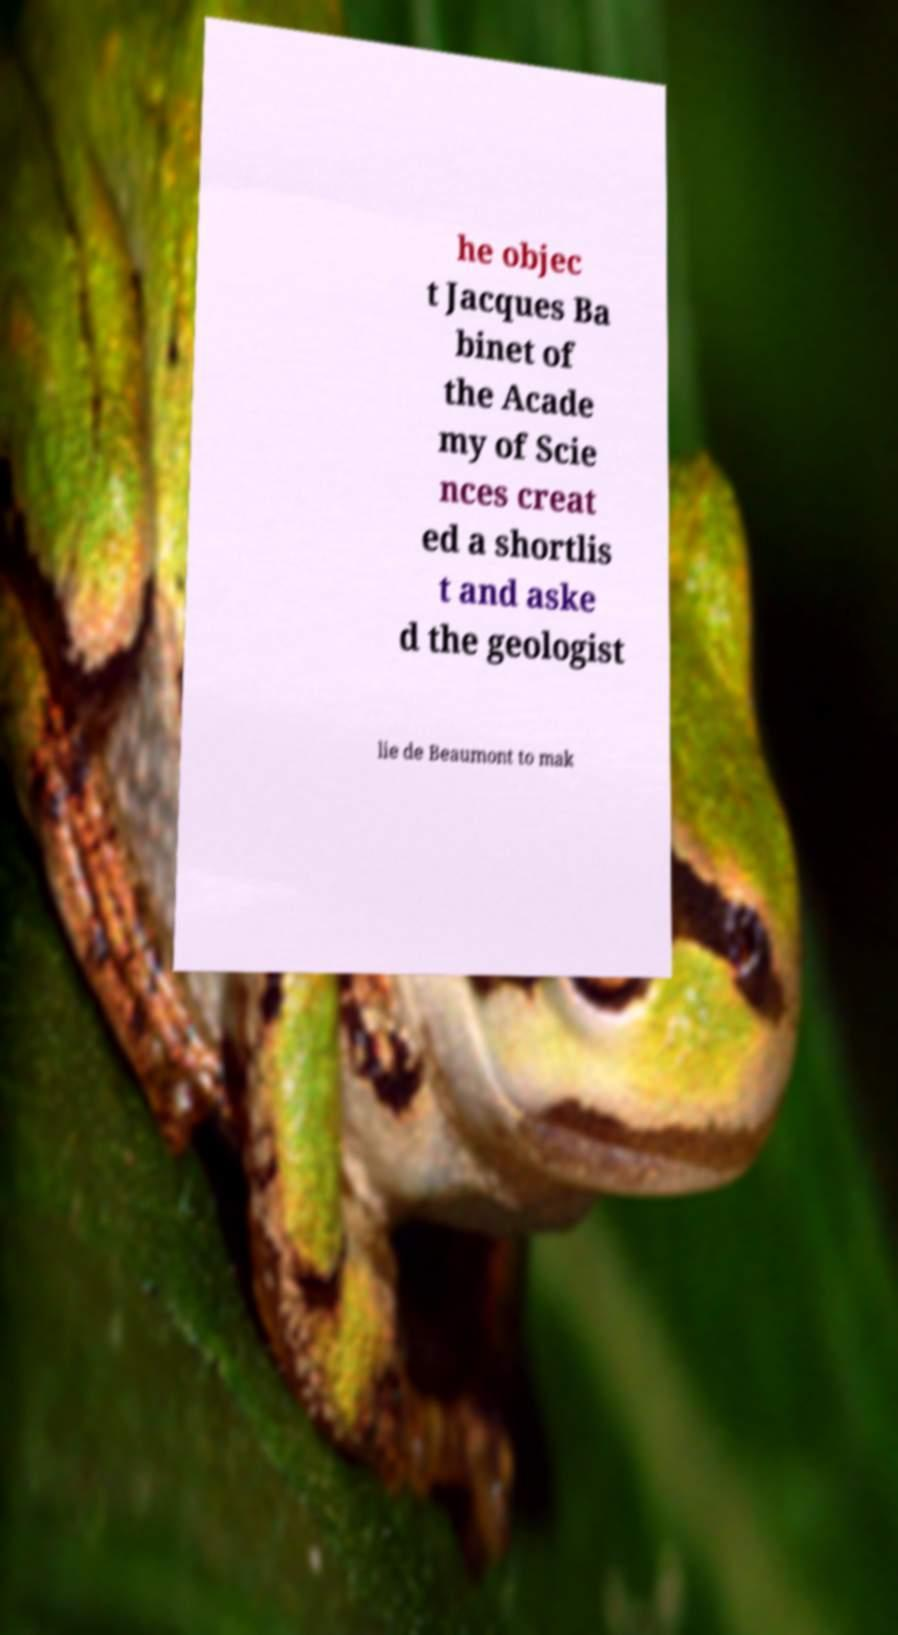Please identify and transcribe the text found in this image. he objec t Jacques Ba binet of the Acade my of Scie nces creat ed a shortlis t and aske d the geologist lie de Beaumont to mak 